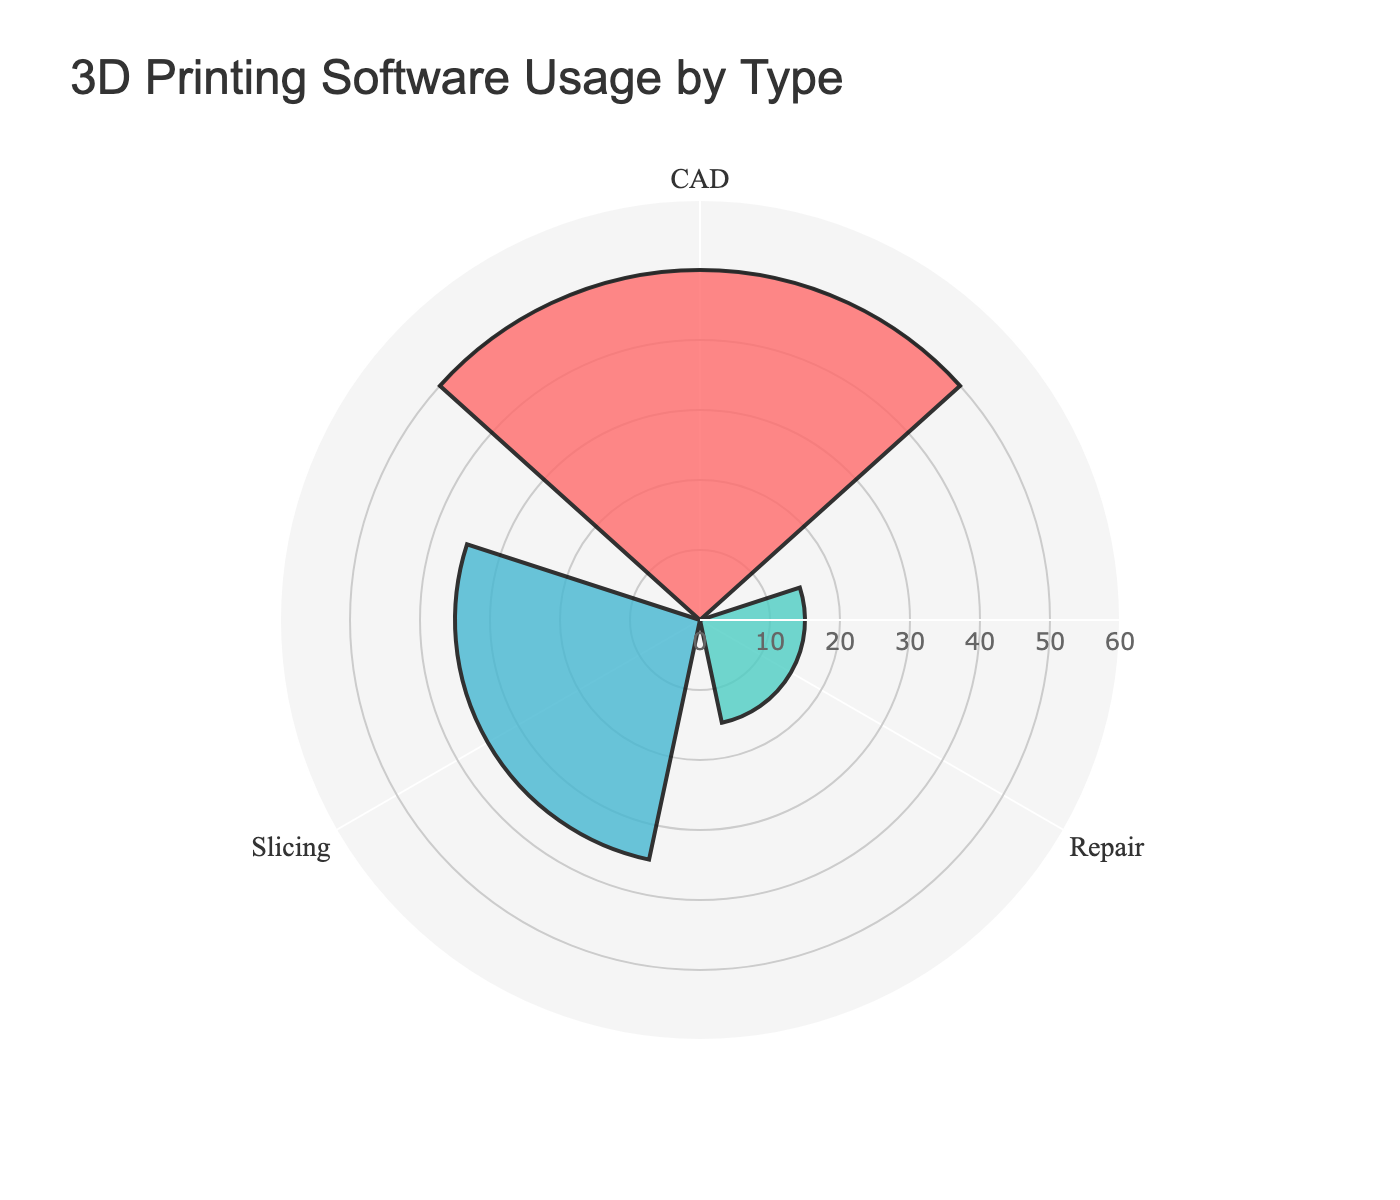How many types of 3D printing software are represented in the figure? The figure shows three groups of software usage by type: CAD, Slicing, and Repair.
Answer: 3 What is the title of the figure? The title of the figure is displayed prominently at the top of the chart.
Answer: 3D Printing Software Usage by Type Which type of 3D printing software has the highest usage percentage? By looking at the bar lengths, CAD has the highest usage percentage with its total usage of displayed software being the highest.
Answer: CAD What is the total usage percentage of slicing software? To find the total, combine the usage percentages for Cura, PrusaSlicer, and Simplify3D: 20 + 10 + 5 = 35.
Answer: 35% What is the difference in usage percentage between CAD software and Repair software? Sum the usage percentages for CAD software (25+15+10=50) and Repair software (10+5=15). The difference is 50 - 15 = 35.
Answer: 35 Which type of software has the least usage percentage? Compare the lengths of the bars; Repair has the least total usage percentage.
Answer: Repair Compare the usage percentage of AutoCAD to Cura. Which is higher? AutoCAD has 25% usage while Cura has 20%. Therefore, AutoCAD's usage is higher.
Answer: AutoCAD What percentage of the total CAD software usage is contributed by AutoCAD? AutoCAD contributes 25% out of the total 50% usage of CAD software. 25/50 = 0.5, so it’s 50%.
Answer: 50% If "Repair" software types are combined, do they have more or less usage than "Fusion 360" alone? Add the usage percentages for Repair software: Meshmixer (10%) and Netfabb (5%) which total to 15%. Fusion 360 alone has 15%. They are equal.
Answer: Equal What is the combined usage percentage of both SketchUp and Simplify3D? Add the usage percentages of SketchUp (10%) and Simplify3D (5%): 10 + 5 = 15.
Answer: 15% 